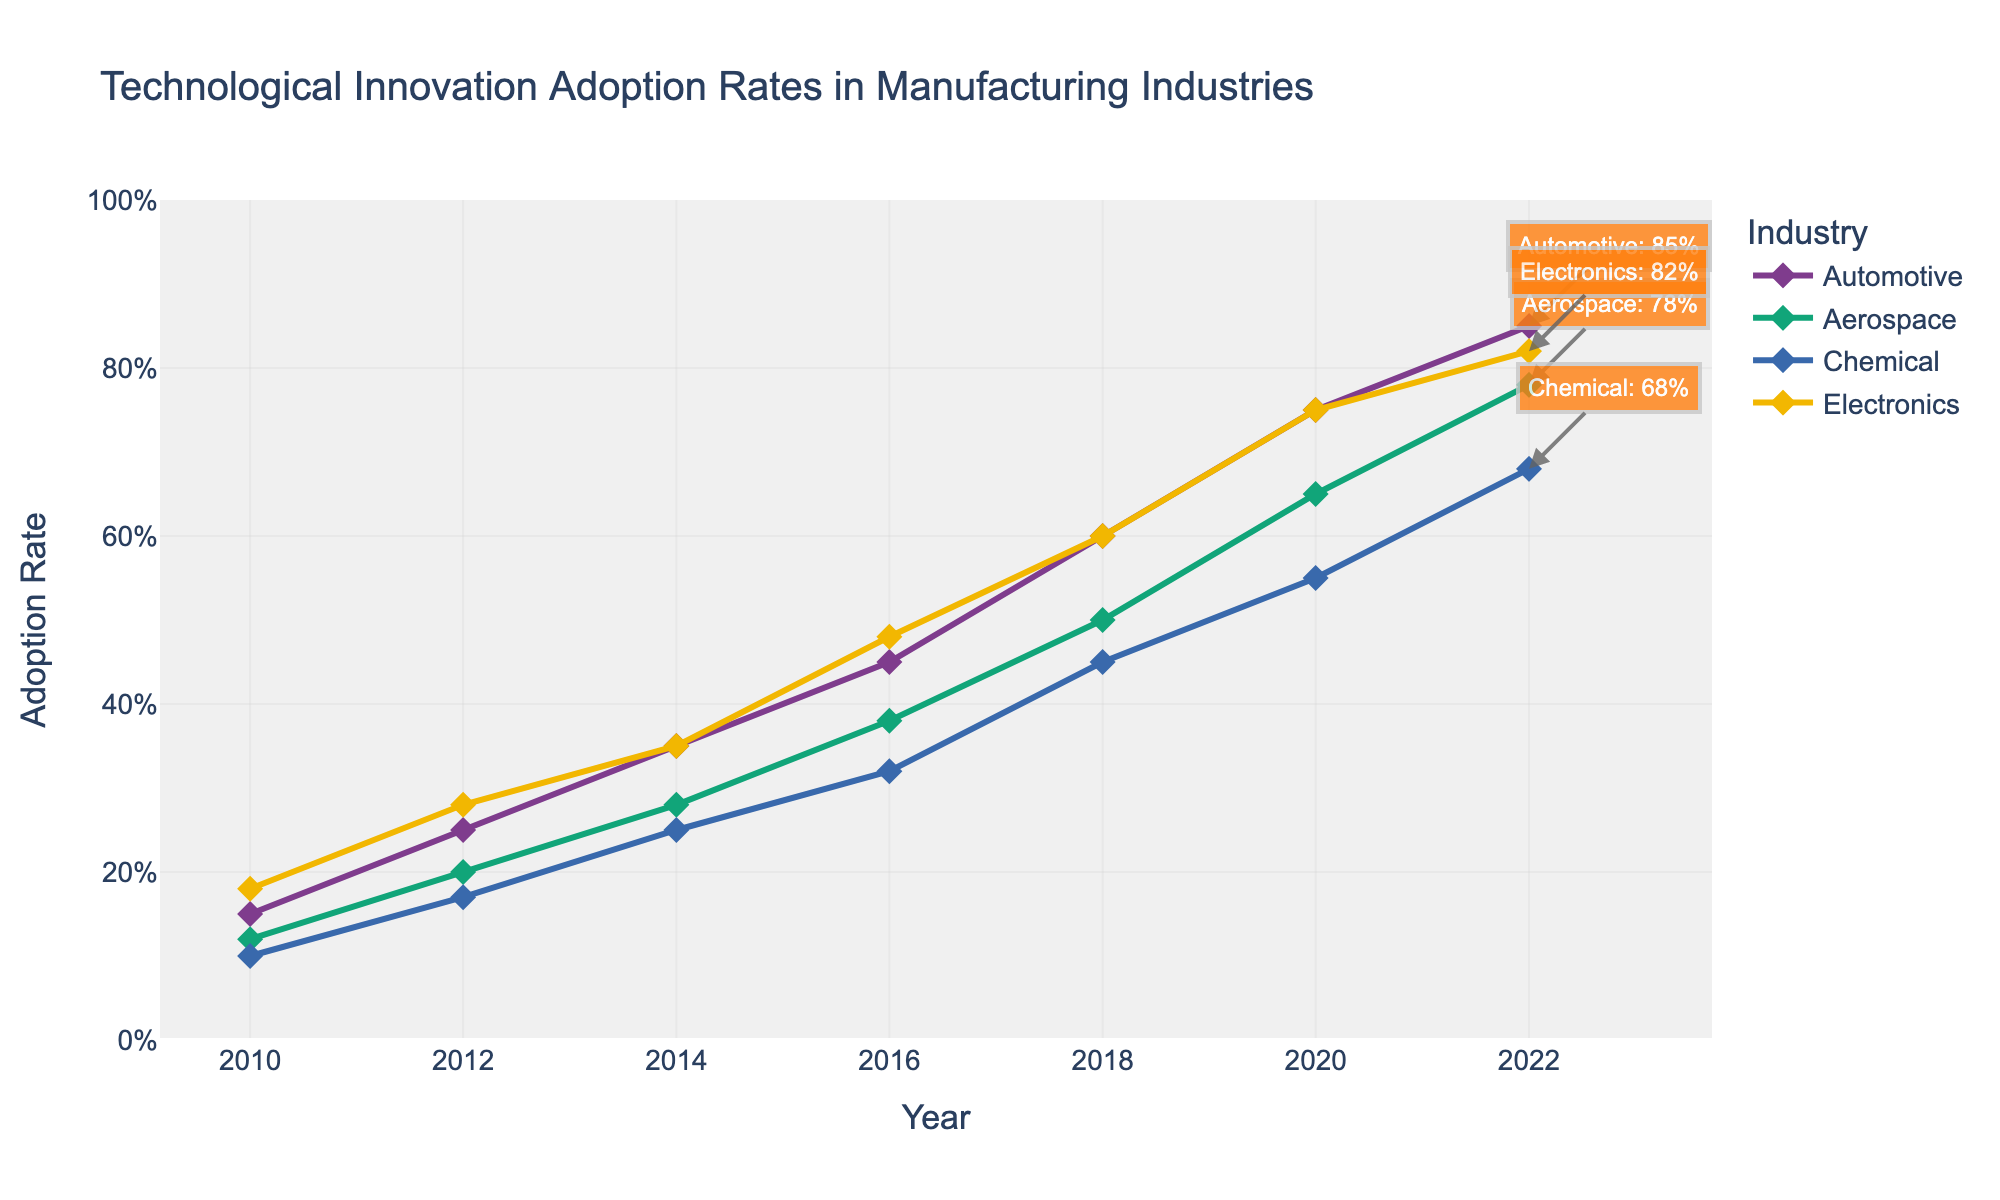what is the title of the figure? The title of a plot is typically located at the top and provides a summary of what the plot represents. In this case, "Technological Innovation Adoption Rates in Manufacturing Industries" is the title of the figure.
Answer: Technological Innovation Adoption Rates in Manufacturing Industries Which industry has the highest technological innovation adoption rate in 2020? By examining the figure at the point corresponding to 2020, the industry with the highest adoption rate would be the curve that peaks highest. In this case, the Electronics industry has the highest adoption rate.
Answer: Electronics How does the adoption rate for the Chemical industry in 2018 compare to 2010? Find the adoption rate for the Chemical industry in both 2010 and 2018 from the plot. The Chemical industry adoption rate increases from 0.10 in 2010 to 0.45 in 2018.
Answer: The adoption rate increased from 0.10 to 0.45 What is the trend observed in the Aerospace industry from 2010 to 2022? By visually inspecting the Aerospace industry's curve from 2010 to 2022 on the plot, we can see if the trend is increasing, decreasing, or constant over time. The plot shows an increasing trend.
Answer: Increasing What is the average adoption rate of the Automotive industry in 2020 and 2022? Locate the adoption rates for the Automotive industry in 2020 and 2022, which are 0.75 and 0.85 respectively. The average is calculated as (0.75 + 0.85) / 2.
Answer: 0.80 Which industry had the slowest growth in technological innovation adoption rates between 2010 and 2022? Compare the starting (2010) and ending (2022) adoption rates for each industry and calculate the difference. The industry with the smallest difference exhibits the slowest growth. The Chemical industry exhibits the slowest growth (0.68 - 0.10 = 0.58).
Answer: Chemical In which year did the Electronics industry surpass an adoption rate of 0.50 for the first time? Identify the point on the Electronics curve where the adoption rate exceeds 0.50 for the first time. This occurs in the year 2016.
Answer: 2016 What is the combined adoption rate for the Aerospace and Chemical industries in 2022? The adoption rates for Aerospace and Chemical in 2022 are 0.78 and 0.68 respectively. Summing these values gives 0.78 + 0.68.
Answer: 1.46 